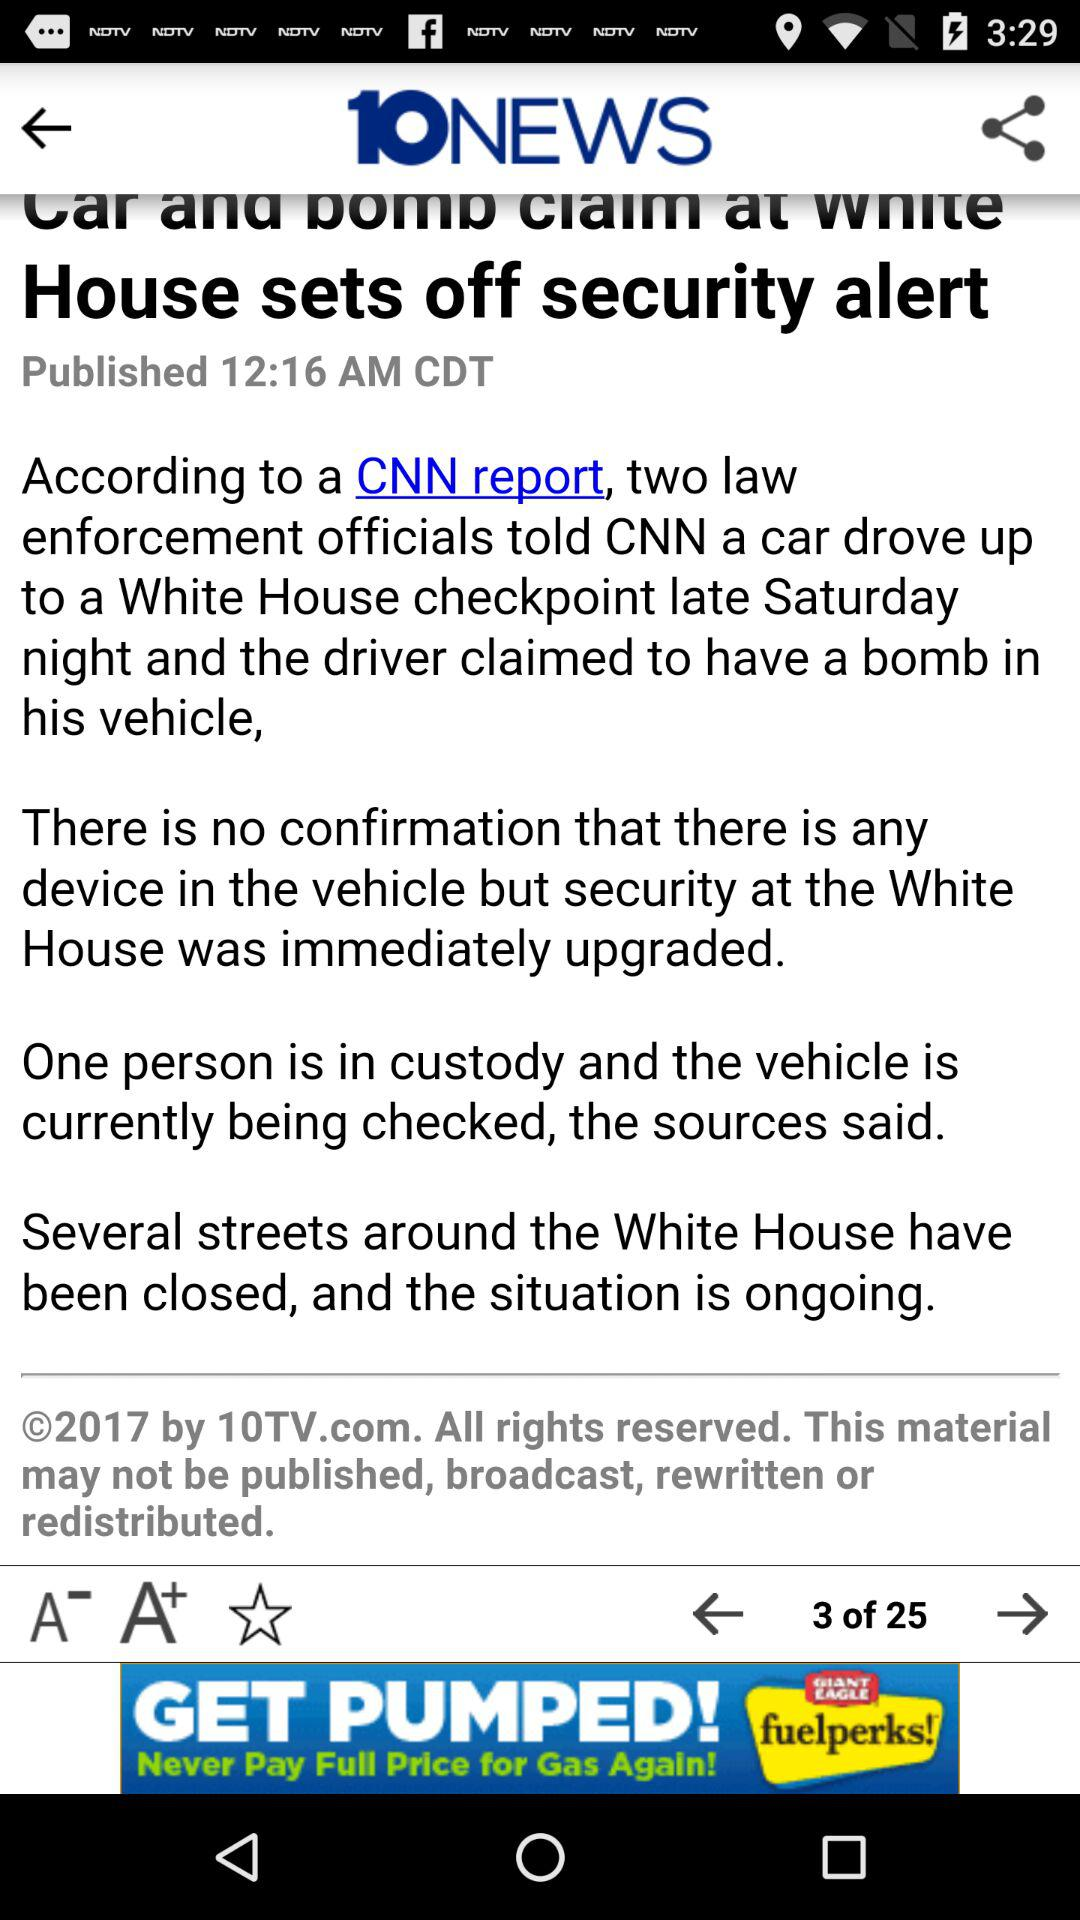What is the published time of the content? The published time is 12:16 AM. 